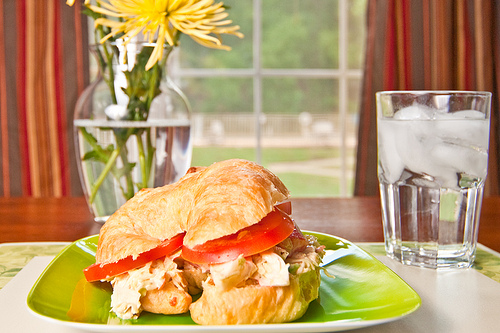In an alternate universe where objects could speak, what would the sandwich and vase converse about? In an alternate universe where objects could speak, the sandwich and vase might have an interesting conversation. The sandwich could ask the vase about its beautiful yellow flowers and how it maintains such vibrant color. The vase might respond by sharing tales of the wonderful garden it came from, regaling stories of blooming under the morning sun and feeling refreshed by morning dew. In turn, the sandwich could share its experience being made in a cozy kitchen, with the kindly chef who meticulously assembled it with the freshest chicken and ripest tomatoes. Together, they might marvel at the serene setting they find themselves in, commenting on the lovely view outside and the pleasure of being part of someone's delightful meal. 